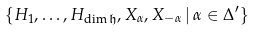<formula> <loc_0><loc_0><loc_500><loc_500>\{ H _ { 1 } , \dots , H _ { \dim \mathfrak { h } } , X _ { \alpha } , X _ { - \alpha } \, | \, \alpha \in \Delta ^ { \prime } \}</formula> 